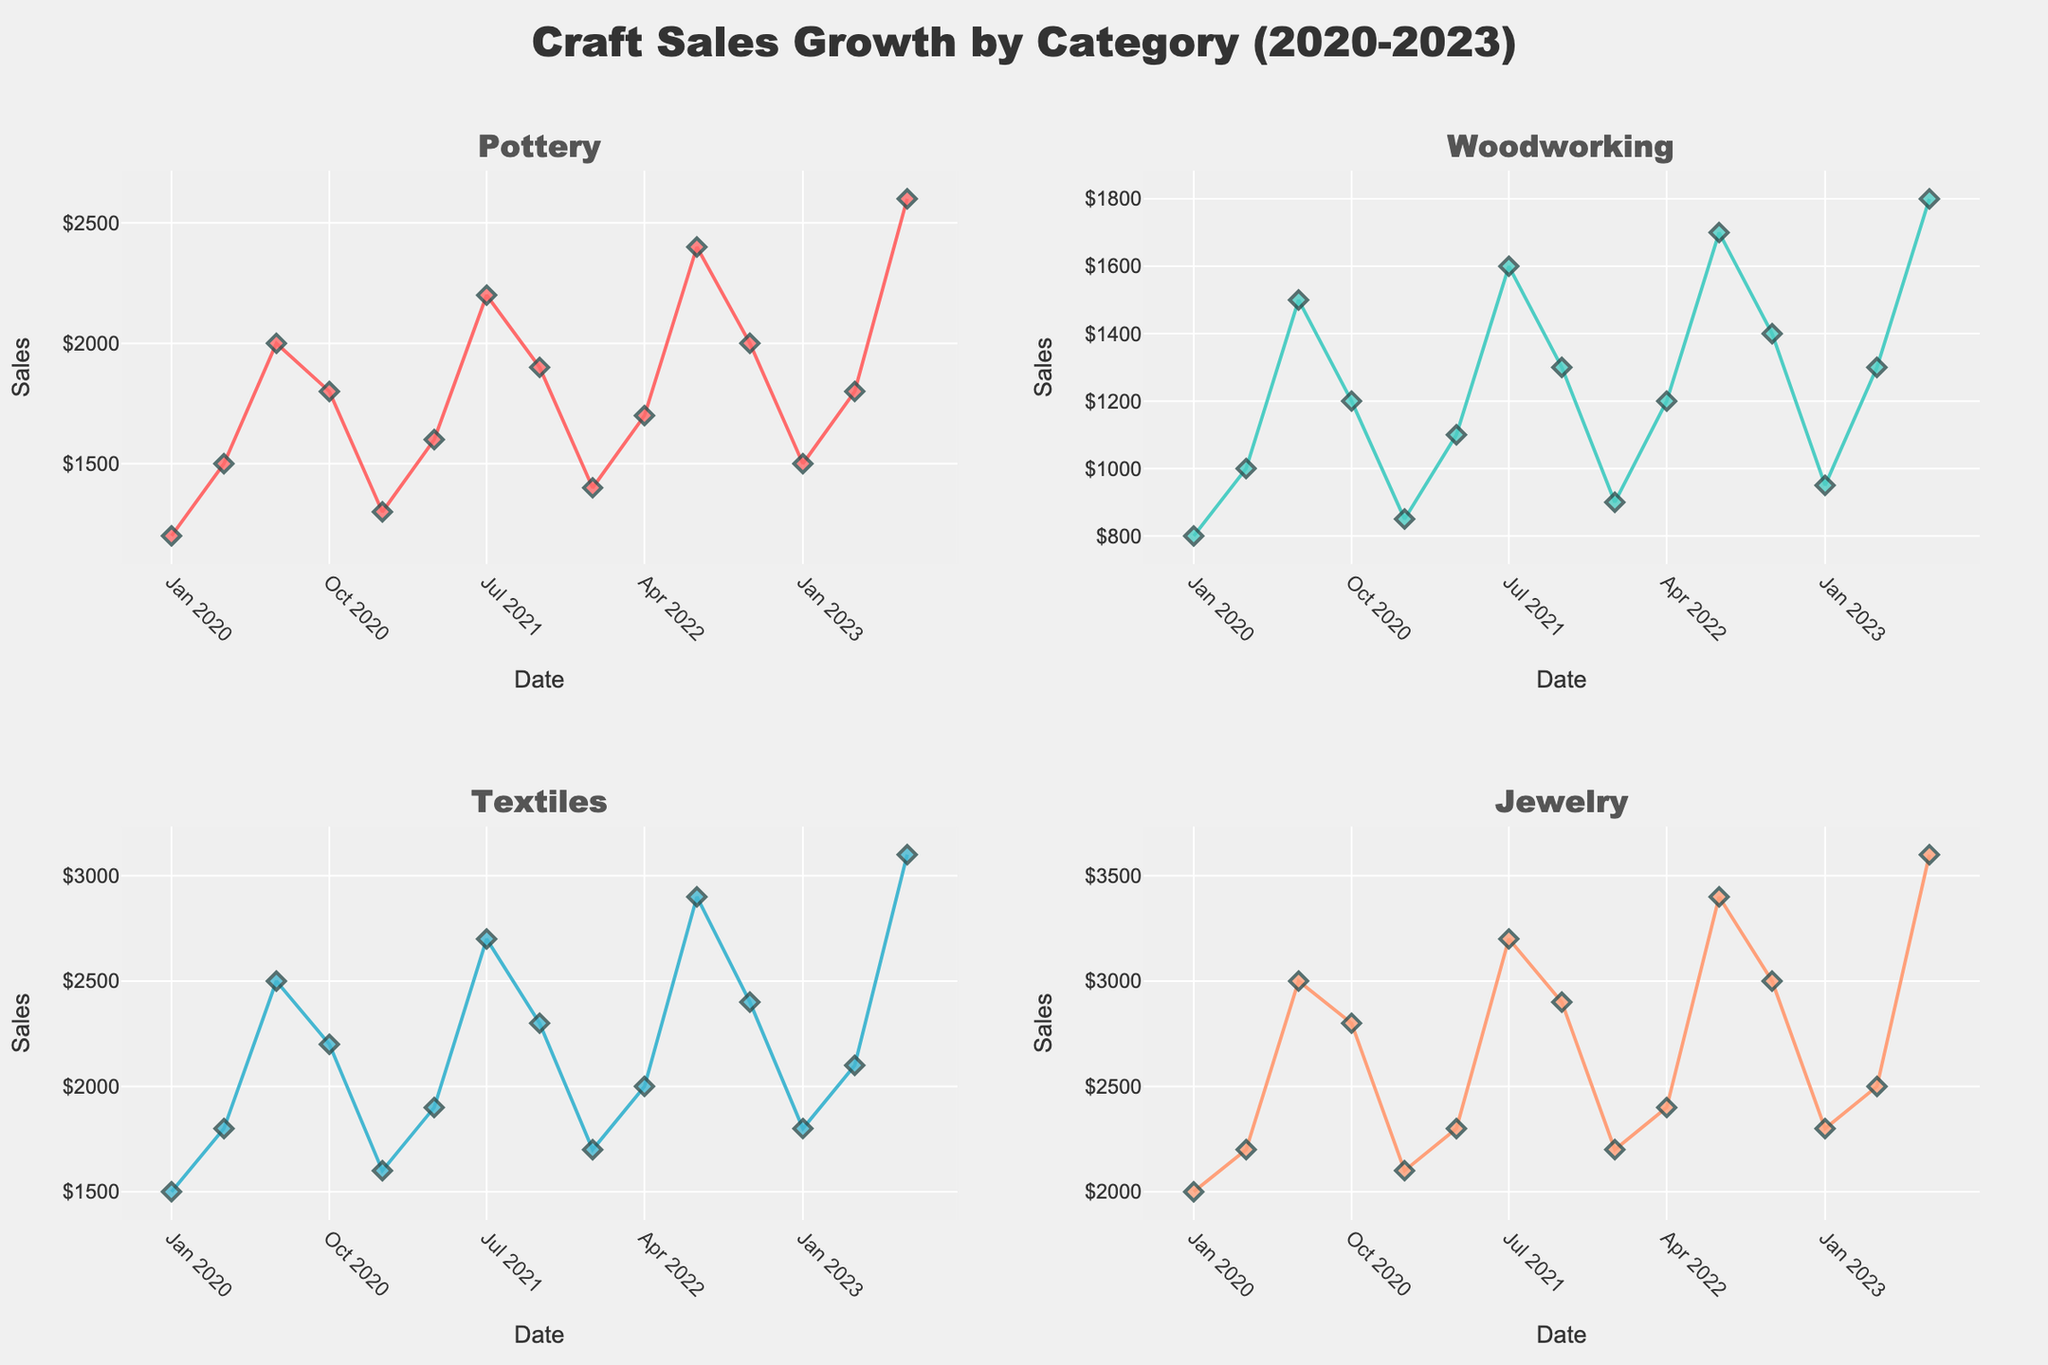What is the title of the figure? The title of the figure is clearly displayed at the top, reading "Craft Sales Growth by Category (2020-2023)".
Answer: Craft Sales Growth by Category (2020-2023) Which craft category had the highest sales in July 2023? By looking at the subplot for July 2023, we can see that Jewelry had the highest sales value marked as 3600.
Answer: Jewelry How do sales of Pottery in July 2020 compare to sales in July 2021? In the Pottery subplot, the sales in July 2020 were 2000 and in July 2021 were 2200. Thus, sales increased from 2000 to 2200.
Answer: Increased by 200 What are the sales trends for Textiles between January of each year? Observing the Textiles subplot, sales rise from January 2020 (1500), to January 2021 (1600), and continue to increase in January 2022 (1700) and January 2023 (1800).
Answer: Increasing trend What seasonal pattern can you observe for Woodworking sales? In the Woodworking subplot, sales increase in April and July each year but fall in October and January. This suggests a seasonal pattern of higher sales in spring and summer.
Answer: Higher in spring/summer Which two months had the closest sales figures for Jewelry in 2020? Looking at the Jewelry subplot for 2020, the sales for January (2000) and April (2200) are the closest, with a difference of 200.
Answer: January and April Compare the sales trend of Pottery and Woodworking from 2020 to 2023. For Pottery, sales consistently rise with a slight dip in October, while for Woodworking, there is a similar rise until October each year, but overall less sharp.
Answer: Pottery sharper rise In which month and year did Textiles see the largest increase in sales from the previous quarter? Checking the Textiles subplot, the largest increase appears between April 2021 (1900) and July 2021 (2700), an increase of 800.
Answer: July 2021 What is the overall trend in Jewelry sales from 2020 to 2023? In the Jewelry subplot, sales increase each year, showing a steady upward trend without significant drops.
Answer: Steady upward trend How does the growth rate of sales compare between Pottery and Textiles over the 4-year period? Pottery grows from 1200 to 2600, whereas Textiles grow from 1500 to 3100. The growth is larger in Textiles over the period.
Answer: Textiles higher growth 